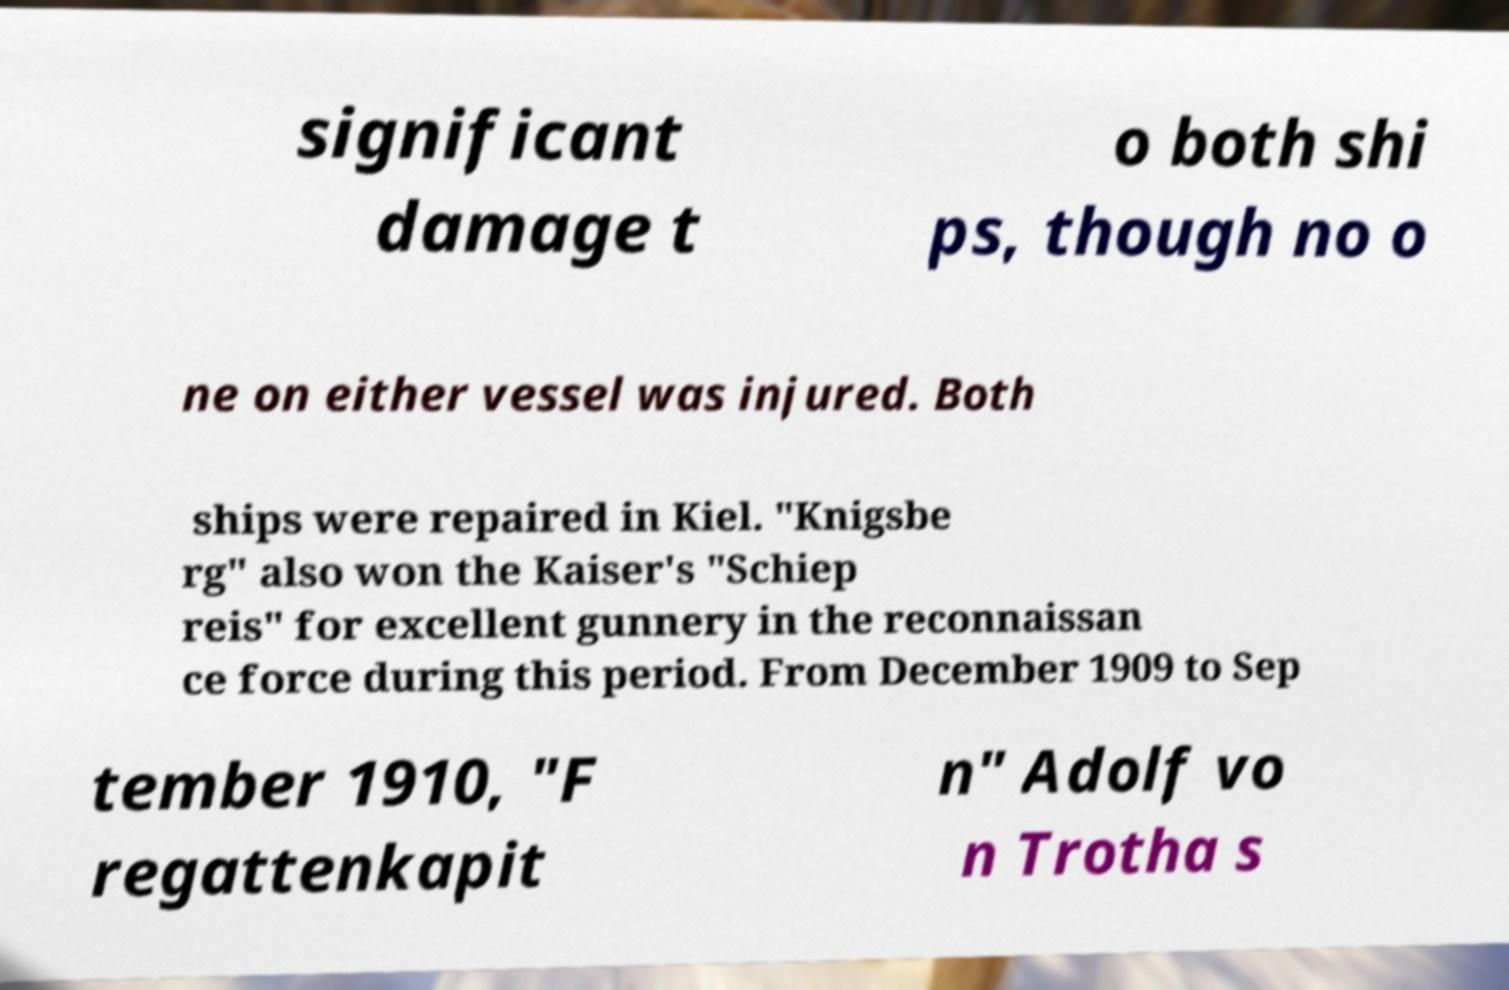Please identify and transcribe the text found in this image. significant damage t o both shi ps, though no o ne on either vessel was injured. Both ships were repaired in Kiel. "Knigsbe rg" also won the Kaiser's "Schiep reis" for excellent gunnery in the reconnaissan ce force during this period. From December 1909 to Sep tember 1910, "F regattenkapit n" Adolf vo n Trotha s 